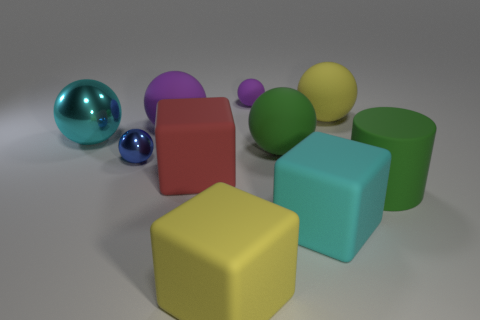Is the number of large cyan cubes behind the red rubber block greater than the number of red blocks that are left of the cyan ball?
Your answer should be compact. No. Is there any other thing that has the same color as the tiny metallic thing?
Your answer should be compact. No. There is a purple ball in front of the tiny purple matte ball; what material is it?
Offer a very short reply. Rubber. Is the size of the cyan metallic thing the same as the blue object?
Keep it short and to the point. No. What number of other objects are the same size as the blue sphere?
Offer a very short reply. 1. Do the rubber cylinder and the small metal object have the same color?
Give a very brief answer. No. There is a big green object that is on the left side of the yellow thing behind the cyan thing in front of the big cylinder; what is its shape?
Offer a very short reply. Sphere. How many objects are metal balls that are to the right of the big cyan metallic object or large balls that are on the left side of the big yellow rubber sphere?
Your response must be concise. 4. There is a yellow object in front of the large yellow object behind the cyan shiny sphere; how big is it?
Provide a succinct answer. Large. There is a small object in front of the small purple matte sphere; is its color the same as the large metal thing?
Give a very brief answer. No. 